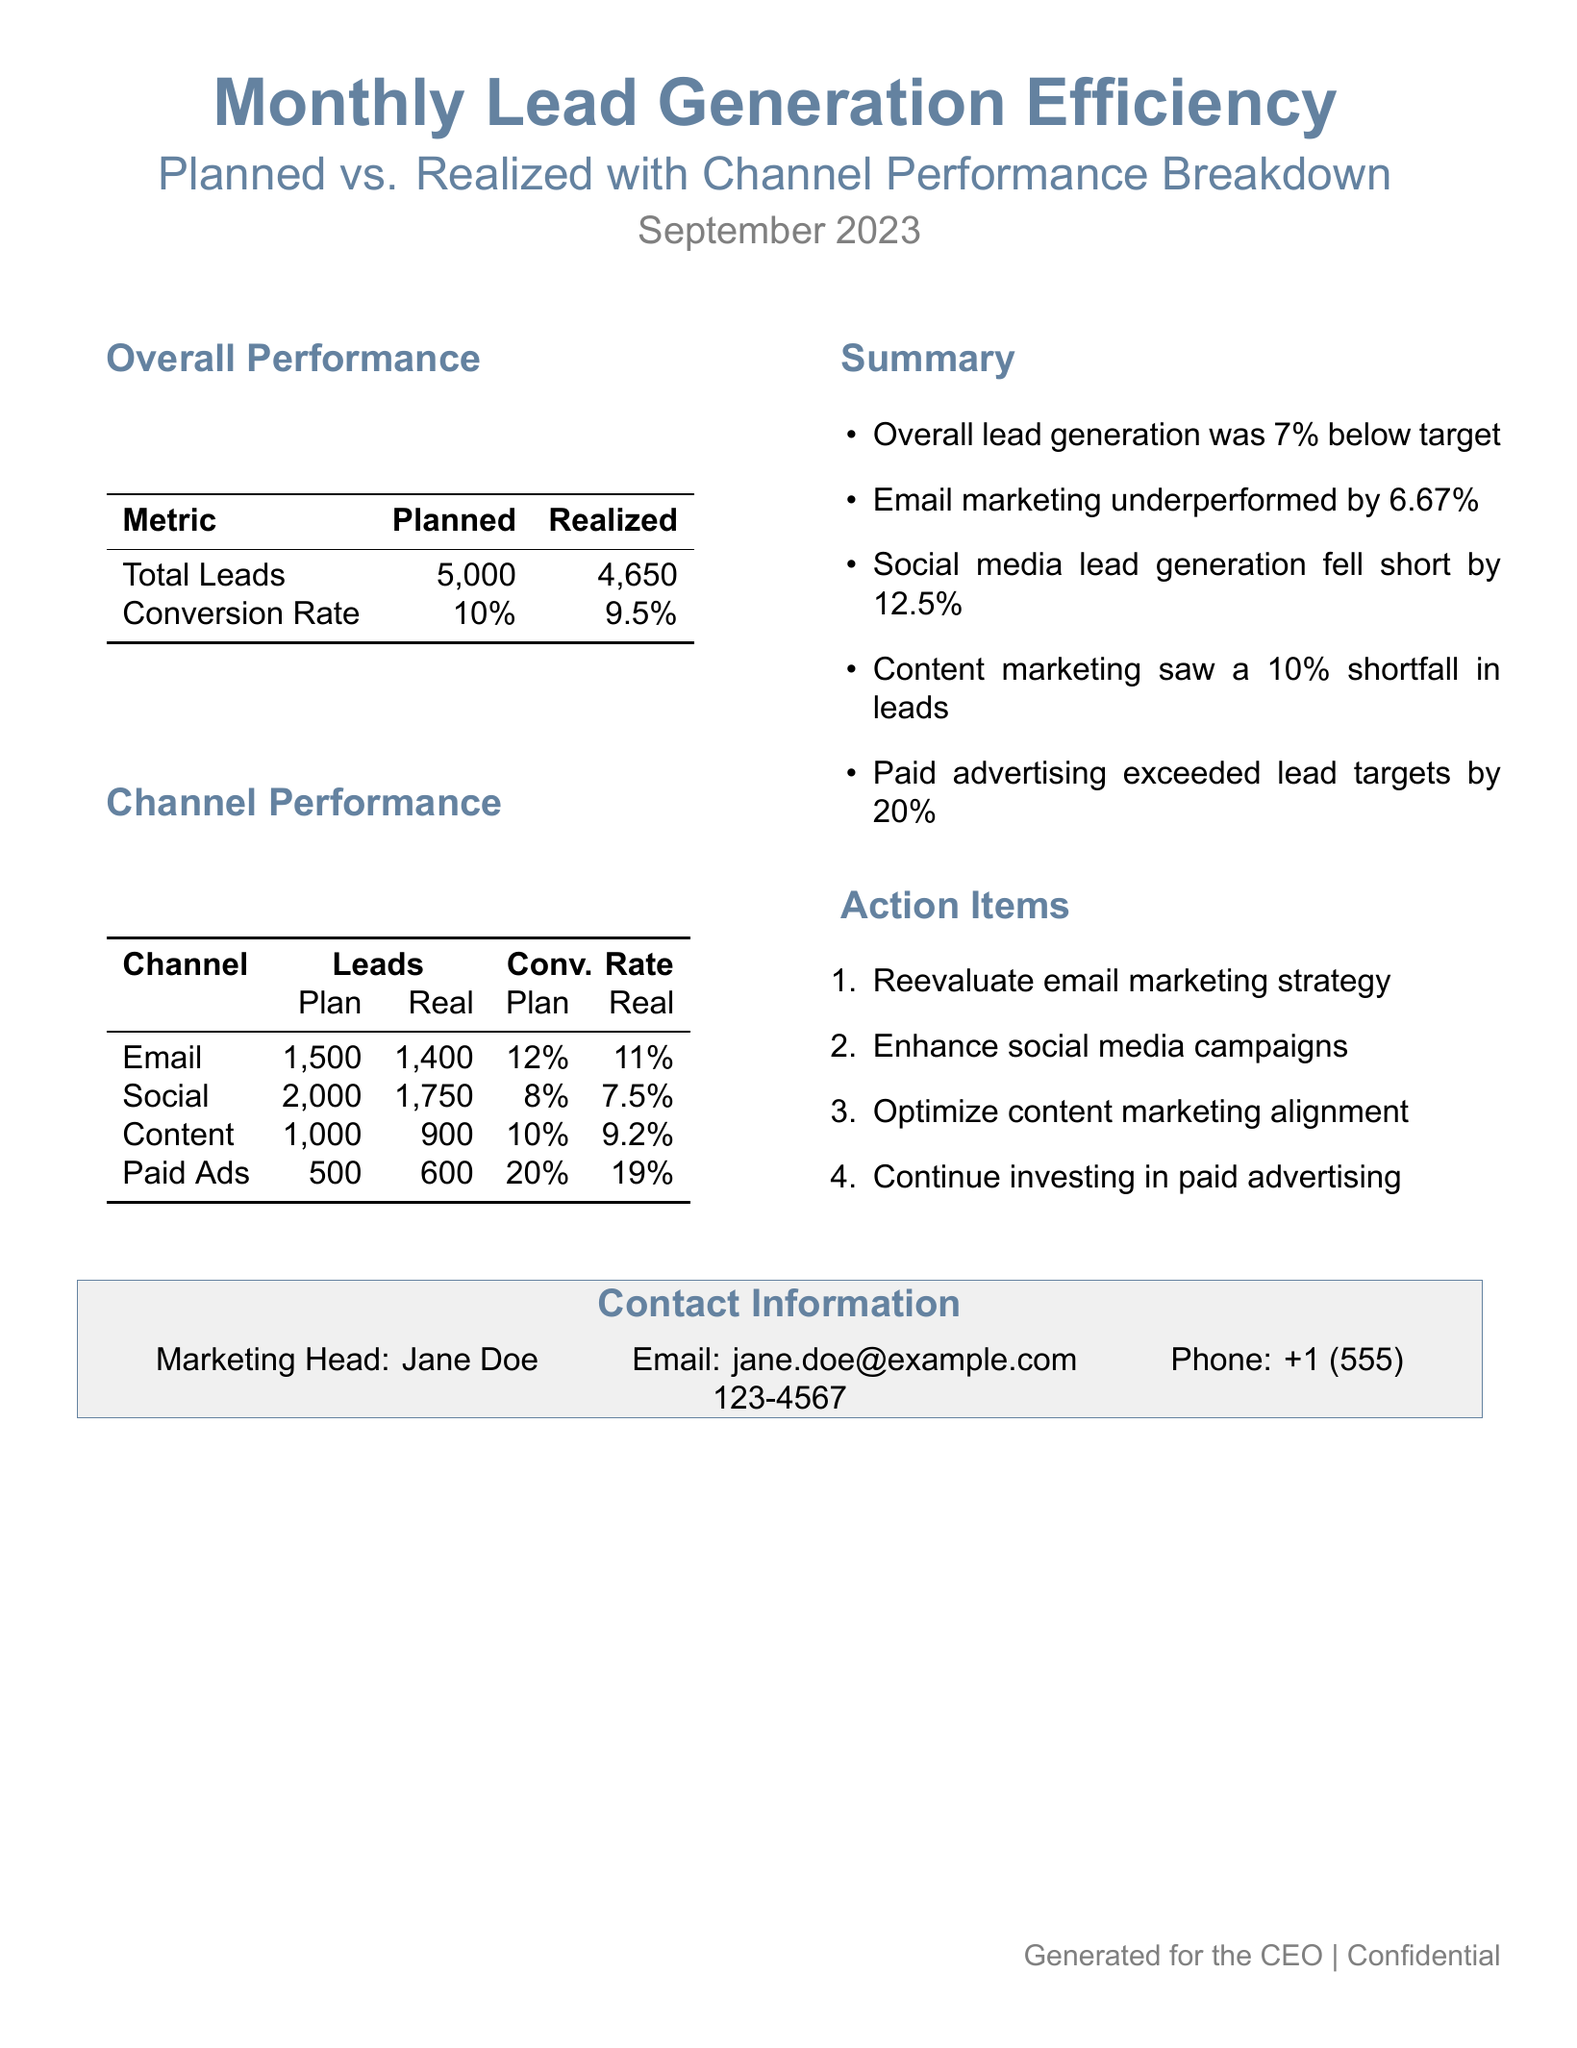What was the total number of planned leads? The total number of planned leads is listed in the overall performance section, which shows a value of 5,000 leads.
Answer: 5,000 How many leads were realized through the Content channel? The realized leads in the Content channel can be found in the channel performance table, where it states 900 leads achieved.
Answer: 900 What is the conversion rate for Paid Ads? The conversion rate for Paid Ads is indicated in the channel performance table, showing a realized rate of 19 percent.
Answer: 19% By what percentage did social media lead generation fall short? The summary states that social media lead generation fell short by 12.5 percent, which is gleaned from overall performance discussions.
Answer: 12.5% What action item is suggested for email marketing? The action items section highlights that the email marketing strategy should be reevaluated as a focus area.
Answer: Reevaluate email marketing strategy What was the total number of realized leads? The total number of realized leads is stated in the overall performance section as 4,650 leads generated.
Answer: 4,650 What was the shortfall in leads for Email marketing? The summary indicates that email marketing underperformed by 6.67 percent, which represents the comparative shortfall from the planned numbers.
Answer: 6.67% Which channel exceeded lead targets, and by how much? The summary section reveals that Paid Ads exceeded lead targets, achieving 600 leads against a plan of 500, indicating a surplus of 100 leads.
Answer: 100 leads What is the planned conversion rate for Content marketing? The planned conversion rate for Content marketing is found in the channel performance table, showing a rate of 10 percent noted for the strategy.
Answer: 10% 